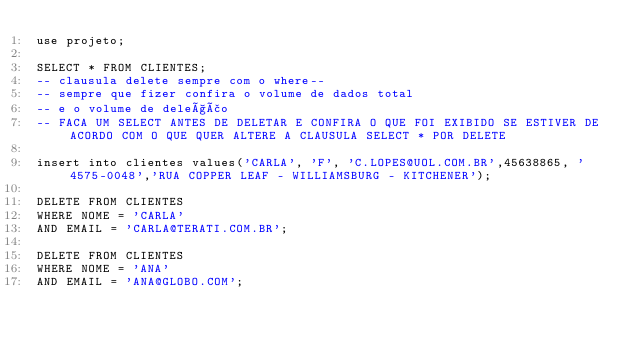Convert code to text. <code><loc_0><loc_0><loc_500><loc_500><_SQL_>use projeto;

SELECT * FROM CLIENTES;
-- clausula delete sempre com o where--
-- sempre que fizer confira o volume de dados total 
-- e o volume de deleção 
-- FACA UM SELECT ANTES DE DELETAR E CONFIRA O QUE FOI EXIBIDO SE ESTIVER DE ACORDO COM O QUE QUER ALTERE A CLAUSULA SELECT * POR DELETE

insert into clientes values('CARLA', 'F', 'C.LOPES@UOL.COM.BR',45638865, '4575-0048','RUA COPPER LEAF - WILLIAMSBURG - KITCHENER');

DELETE FROM CLIENTES
WHERE NOME = 'CARLA'
AND EMAIL = 'CARLA@TERATI.COM.BR';

DELETE FROM CLIENTES
WHERE NOME = 'ANA'
AND EMAIL = 'ANA@GLOBO.COM';</code> 